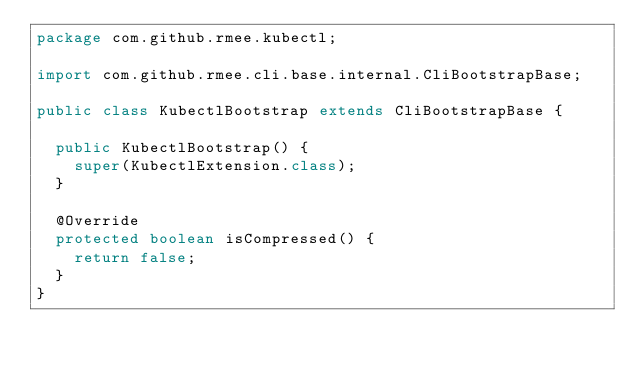Convert code to text. <code><loc_0><loc_0><loc_500><loc_500><_Java_>package com.github.rmee.kubectl;

import com.github.rmee.cli.base.internal.CliBootstrapBase;

public class KubectlBootstrap extends CliBootstrapBase {

	public KubectlBootstrap() {
		super(KubectlExtension.class);
	}

	@Override
	protected boolean isCompressed() {
		return false;
	}
}
</code> 